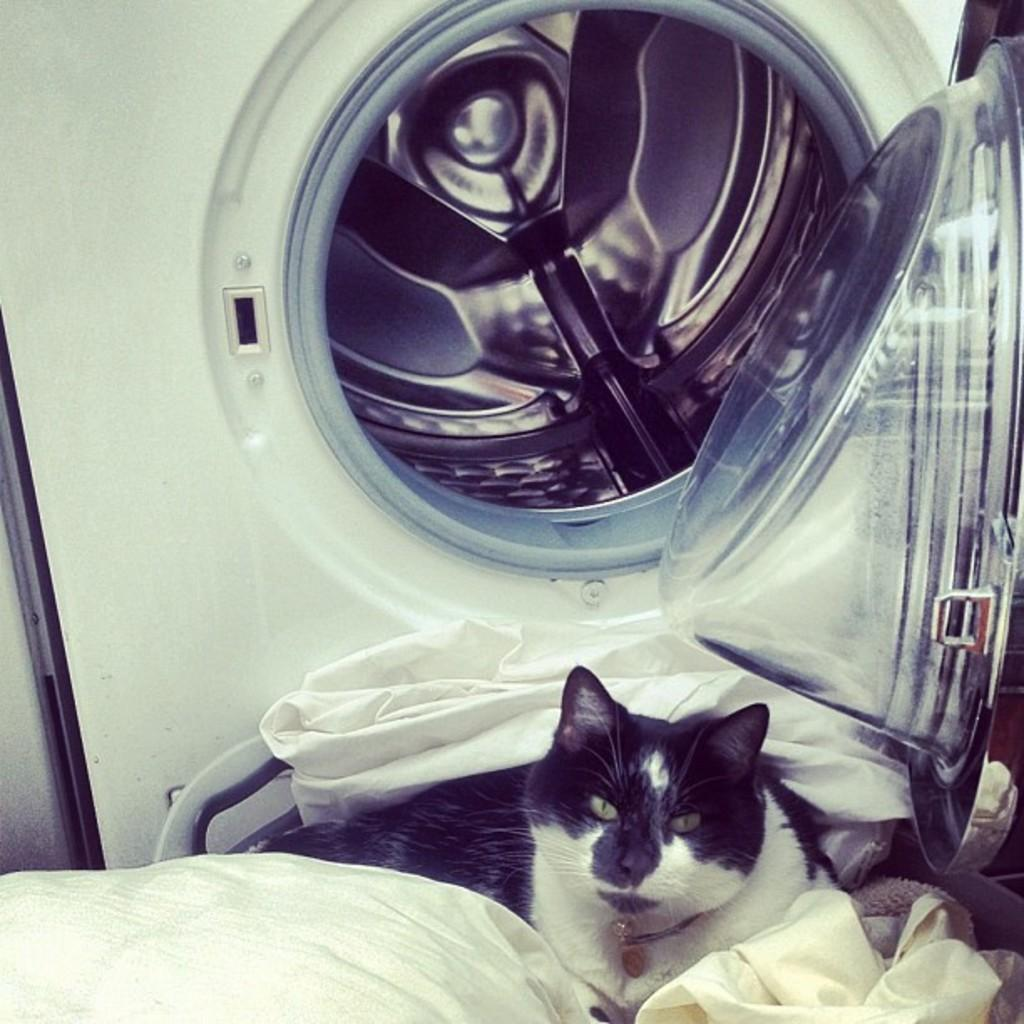What type of animal is present in the image? There is a cat in the image. What else can be seen in the image besides the cat? There are clothes visible in the image. Can you identify any appliances in the image? Yes, there appears to be a washing machine in the image. How many brothers does the cat have in the image? There are no brothers mentioned or depicted in the image, as it features a cat and other objects. 